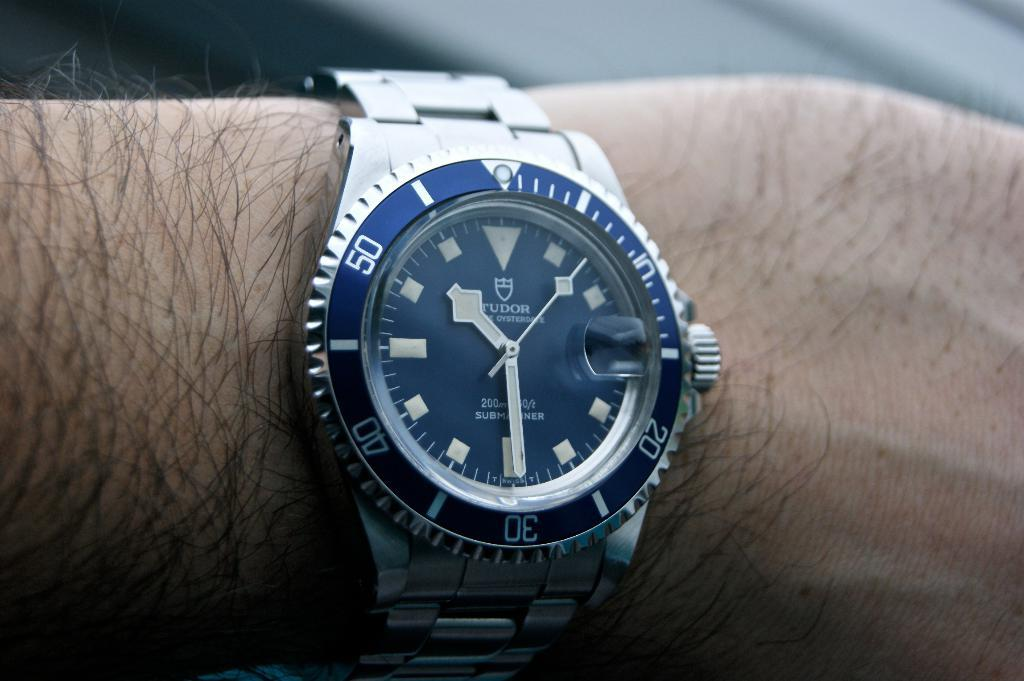<image>
Write a terse but informative summary of the picture. A person is wearing a Tudor wristwatch with a blue face indicating that the time is 10:30. 